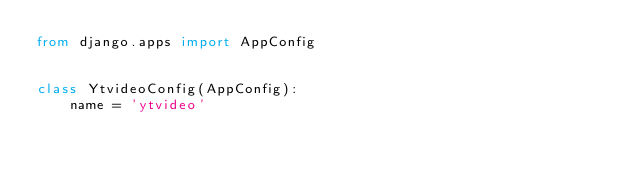Convert code to text. <code><loc_0><loc_0><loc_500><loc_500><_Python_>from django.apps import AppConfig


class YtvideoConfig(AppConfig):
    name = 'ytvideo'
</code> 